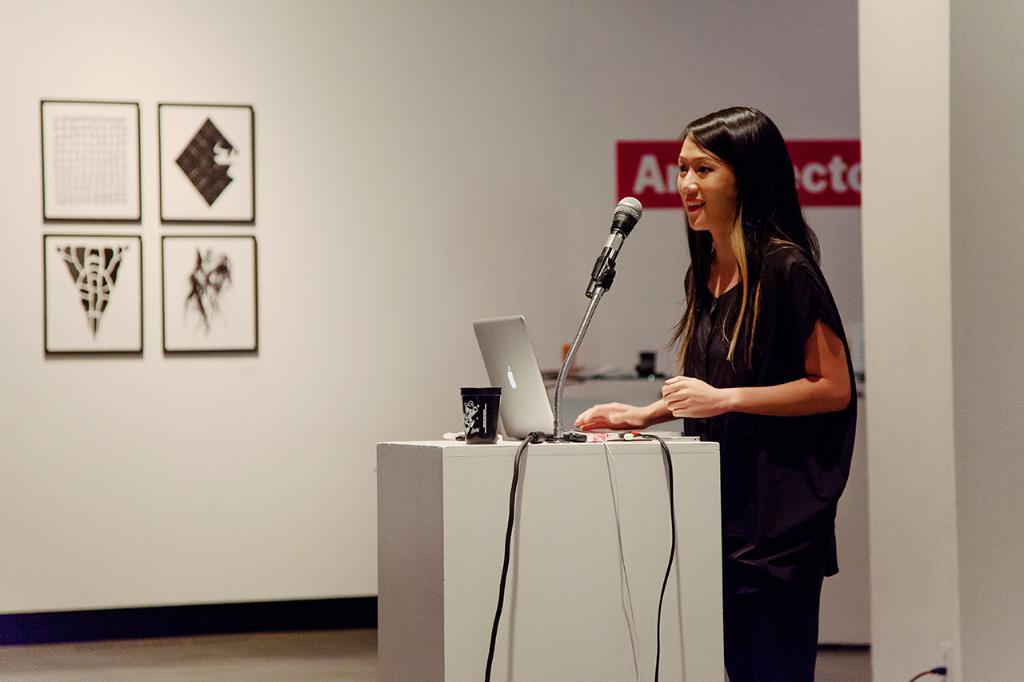Could you give a brief overview of what you see in this image? In this image we can see a person standing and a table is placed in front of her. On the table there are mic, laptop, tumbler and cables. In the background we can see wall hangings attached to the wall and floor. 